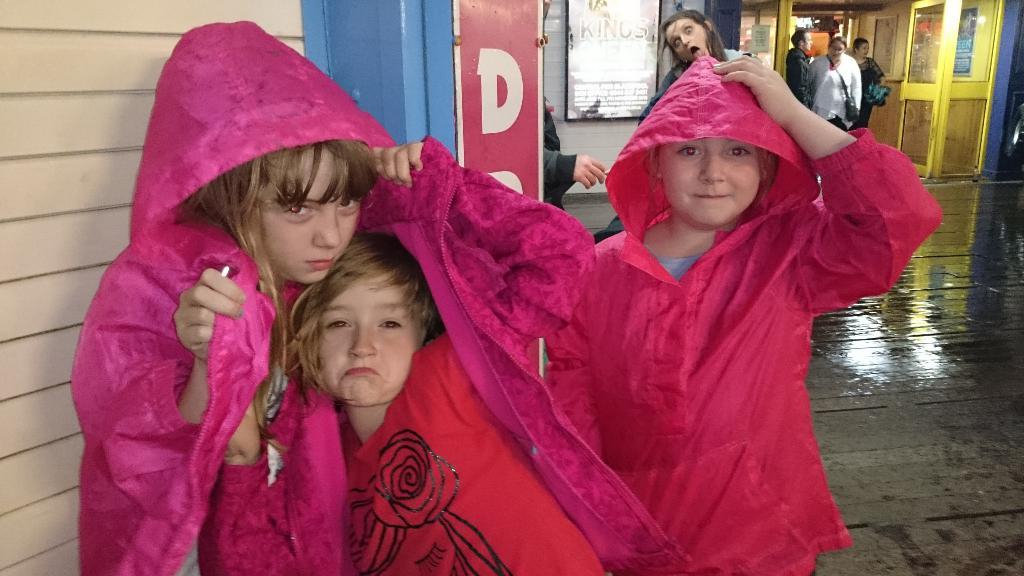Who is present in the image? There are children and people in the image. What are some of the actions being performed by the people in the image? Some people are standing, and some are walking in the image. What structure is visible in the image? The entrance of a building is visible in the image. What information is displayed on the board in the image? There is a board with text in the image. What type of coast can be seen in the image? There is no coast present in the image. What is the top-selling item in the image? The image does not depict any items for sale, so it is not possible to determine the top-selling item. 